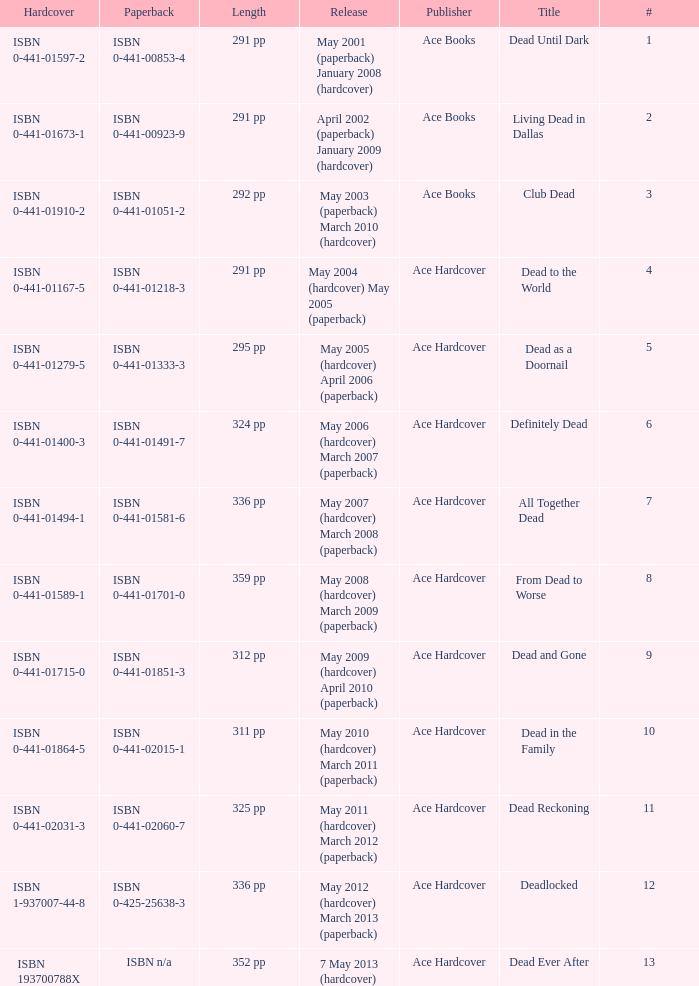Who pubilshed isbn 1-937007-44-8? Ace Hardcover. 